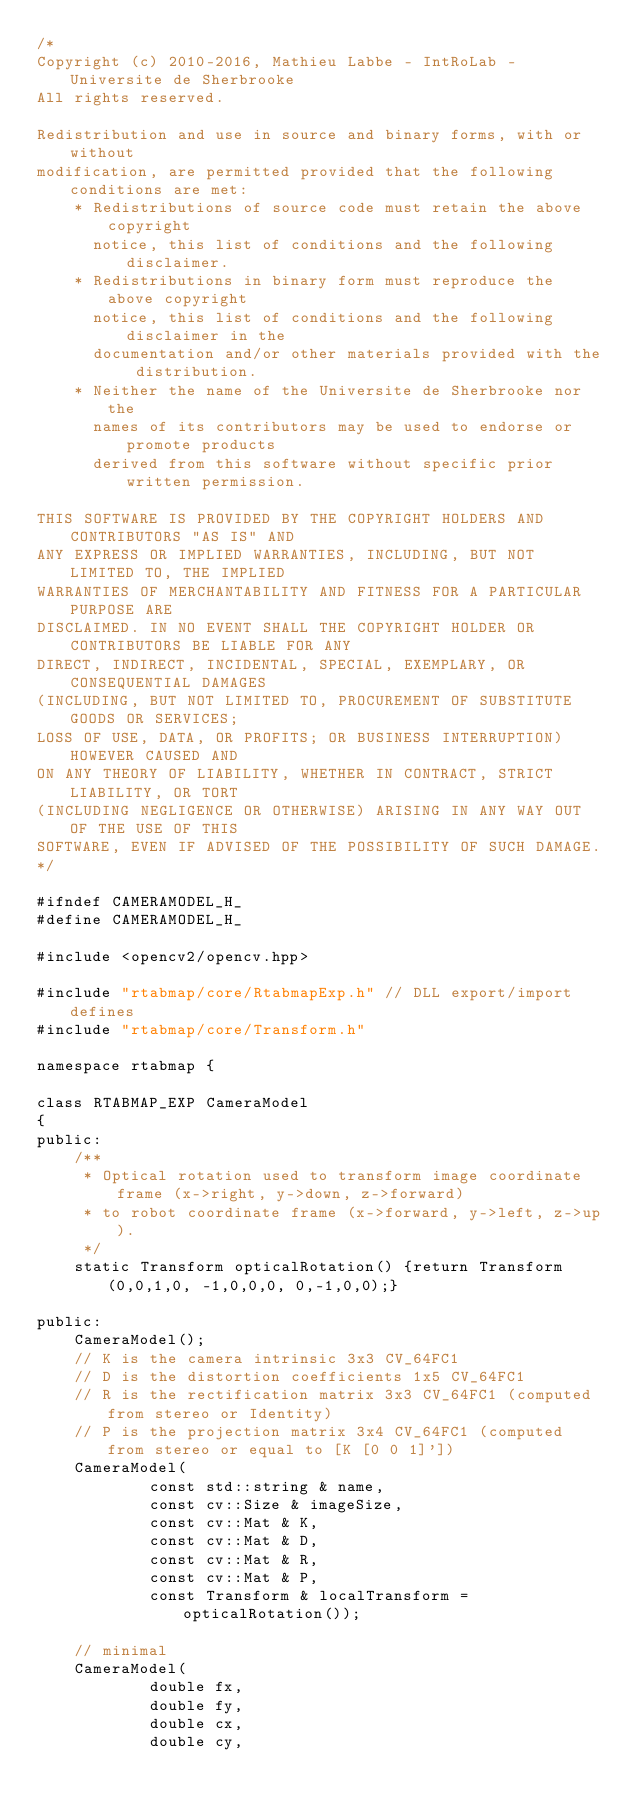Convert code to text. <code><loc_0><loc_0><loc_500><loc_500><_C_>/*
Copyright (c) 2010-2016, Mathieu Labbe - IntRoLab - Universite de Sherbrooke
All rights reserved.

Redistribution and use in source and binary forms, with or without
modification, are permitted provided that the following conditions are met:
    * Redistributions of source code must retain the above copyright
      notice, this list of conditions and the following disclaimer.
    * Redistributions in binary form must reproduce the above copyright
      notice, this list of conditions and the following disclaimer in the
      documentation and/or other materials provided with the distribution.
    * Neither the name of the Universite de Sherbrooke nor the
      names of its contributors may be used to endorse or promote products
      derived from this software without specific prior written permission.

THIS SOFTWARE IS PROVIDED BY THE COPYRIGHT HOLDERS AND CONTRIBUTORS "AS IS" AND
ANY EXPRESS OR IMPLIED WARRANTIES, INCLUDING, BUT NOT LIMITED TO, THE IMPLIED
WARRANTIES OF MERCHANTABILITY AND FITNESS FOR A PARTICULAR PURPOSE ARE
DISCLAIMED. IN NO EVENT SHALL THE COPYRIGHT HOLDER OR CONTRIBUTORS BE LIABLE FOR ANY
DIRECT, INDIRECT, INCIDENTAL, SPECIAL, EXEMPLARY, OR CONSEQUENTIAL DAMAGES
(INCLUDING, BUT NOT LIMITED TO, PROCUREMENT OF SUBSTITUTE GOODS OR SERVICES;
LOSS OF USE, DATA, OR PROFITS; OR BUSINESS INTERRUPTION) HOWEVER CAUSED AND
ON ANY THEORY OF LIABILITY, WHETHER IN CONTRACT, STRICT LIABILITY, OR TORT
(INCLUDING NEGLIGENCE OR OTHERWISE) ARISING IN ANY WAY OUT OF THE USE OF THIS
SOFTWARE, EVEN IF ADVISED OF THE POSSIBILITY OF SUCH DAMAGE.
*/

#ifndef CAMERAMODEL_H_
#define CAMERAMODEL_H_

#include <opencv2/opencv.hpp>

#include "rtabmap/core/RtabmapExp.h" // DLL export/import defines
#include "rtabmap/core/Transform.h"

namespace rtabmap {

class RTABMAP_EXP CameraModel
{
public:
	/**
	 * Optical rotation used to transform image coordinate frame (x->right, y->down, z->forward)
	 * to robot coordinate frame (x->forward, y->left, z->up).
	 */
	static Transform opticalRotation() {return Transform(0,0,1,0, -1,0,0,0, 0,-1,0,0);}

public:
	CameraModel();
	// K is the camera intrinsic 3x3 CV_64FC1
	// D is the distortion coefficients 1x5 CV_64FC1
	// R is the rectification matrix 3x3 CV_64FC1 (computed from stereo or Identity)
	// P is the projection matrix 3x4 CV_64FC1 (computed from stereo or equal to [K [0 0 1]'])
	CameraModel(
			const std::string & name,
			const cv::Size & imageSize,
			const cv::Mat & K,
			const cv::Mat & D,
			const cv::Mat & R,
			const cv::Mat & P,
			const Transform & localTransform = opticalRotation());

	// minimal
	CameraModel(
			double fx,
			double fy,
			double cx,
			double cy,</code> 